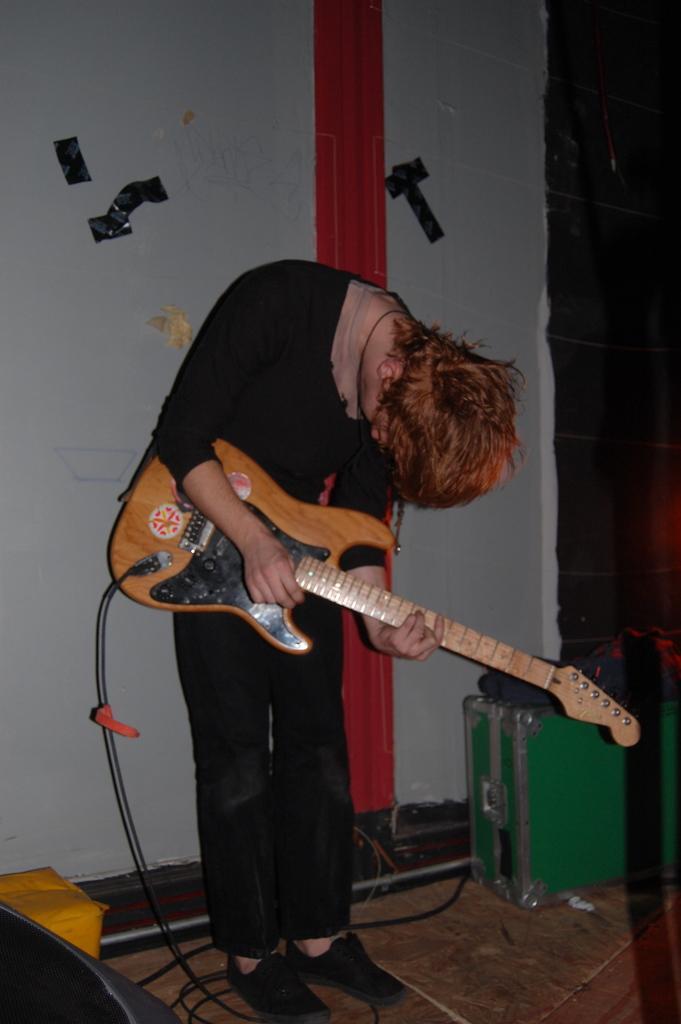In one or two sentences, can you explain what this image depicts? I could see a person holding a guitar in his hands and bending bowing down. He is wearing a black color shirt and black color pant with black color shoes. The guitar is connected to a cable which is connected to some box in the right corner of the picture the box is green in color. In the background i could see the wall with red beam in the middle and some black curtain in the right corner of the picture. The wall has some black black straps. In the left corner of the picture could see some yellow colored pillow and black colored chair. 